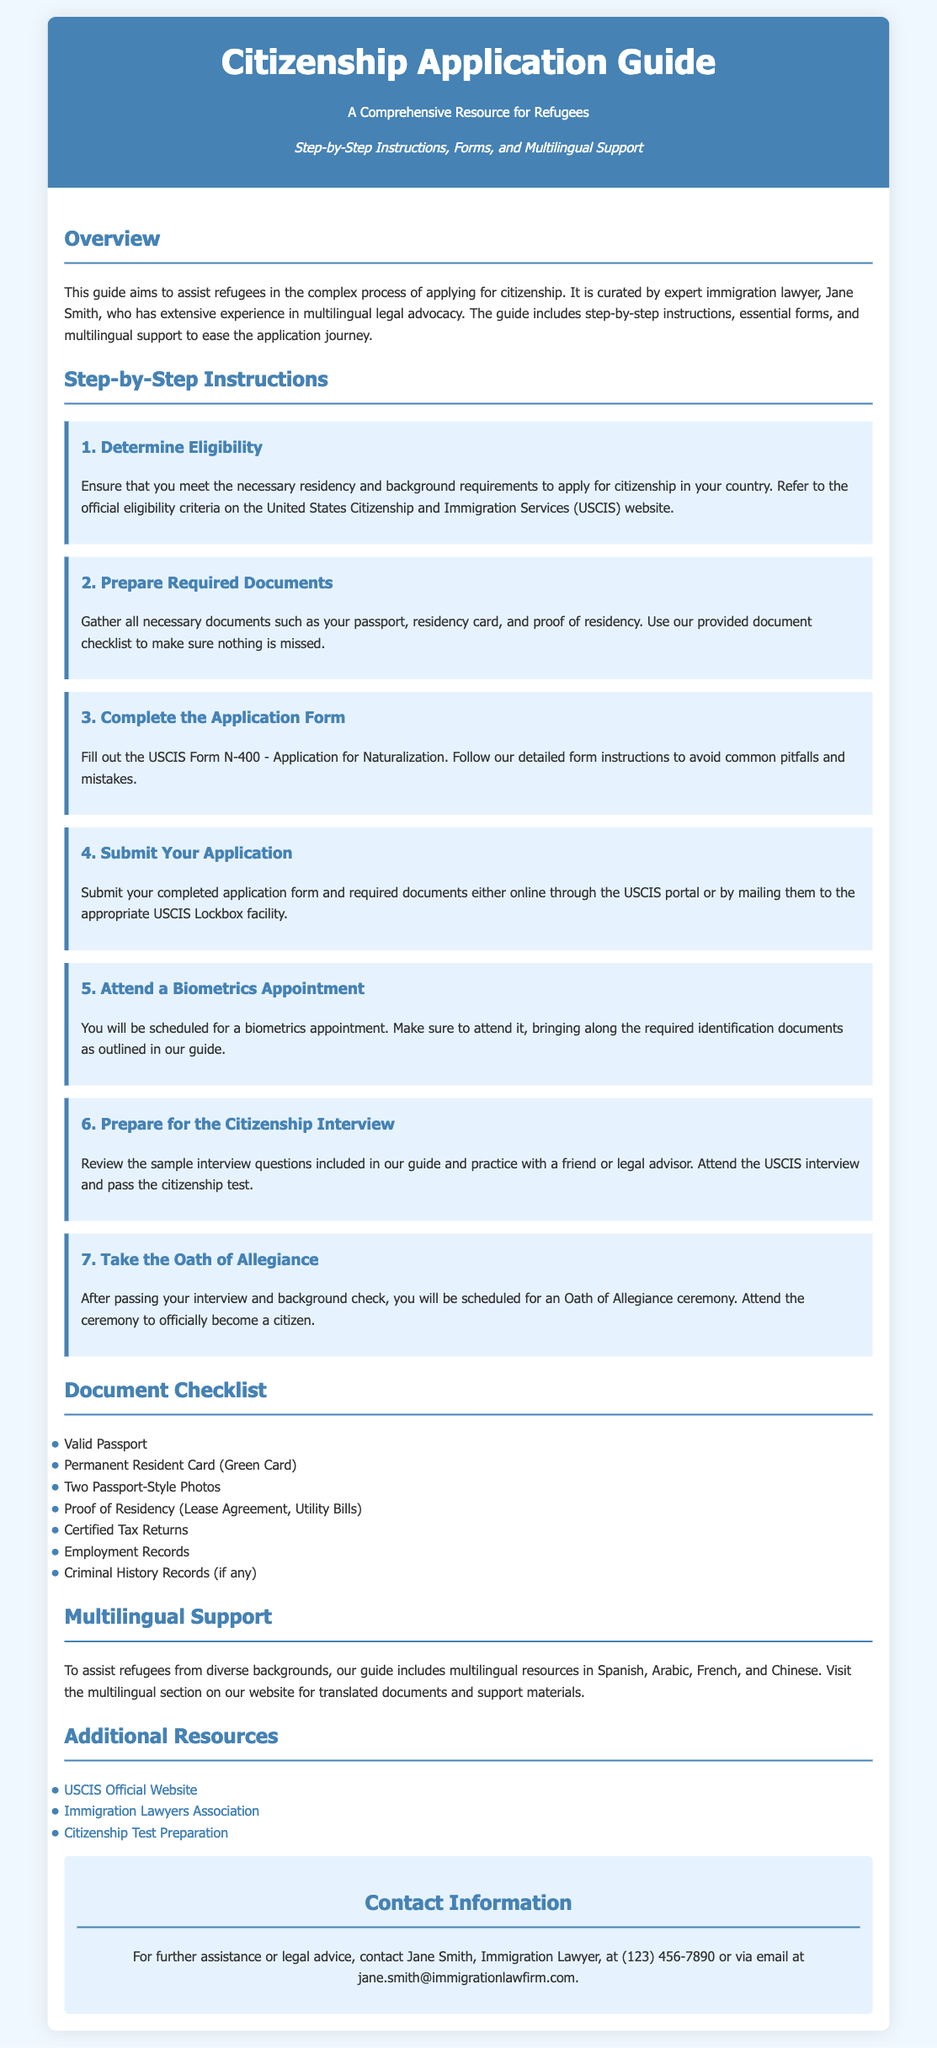What is the title of the guide? The title of the guide is prominently displayed in the header section of the document.
Answer: Citizenship Application Guide Who is the author of the guide? The author is mentioned in the overview section, indicating their expertise in immigration law.
Answer: Jane Smith What form needs to be completed for the application? This information is provided in the step-by-step instructions about the application process.
Answer: USCIS Form N-400 How many steps are there in the application process? The steps are numbered in the document, indicating the total in the list.
Answer: Seven What is one of the required documents for the application? The document checklist lists multiple required documents.
Answer: Valid Passport Which languages are included in the multilingual support section? The multilingual support section specifies the languages available for assistance.
Answer: Spanish, Arabic, French, and Chinese What is the last step in the citizenship application process? The last step is outlined in the step-by-step instructions regarding the completion of the process.
Answer: Take the Oath of Allegiance How can Jane Smith be contacted for legal advice? The contact information section provides details on how to reach Jane Smith for further assistance.
Answer: (123) 456-7890 or jane.smith@immigrationlawfirm.com What organization’s website is listed as a resource? The document includes specific links to various organizations that provide additional support.
Answer: USCIS Official Website 